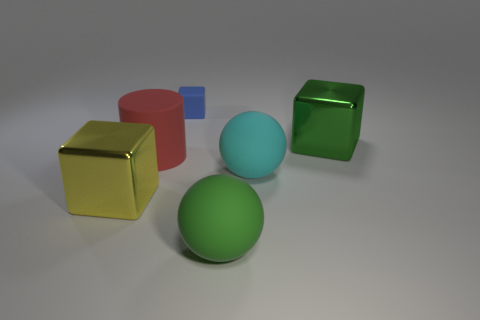How many geometric shapes are visible in the image? There are five distinct geometric shapes in the image: a sphere, a cube, a cylinder, a smaller cube, and a torus, each with a different color. 